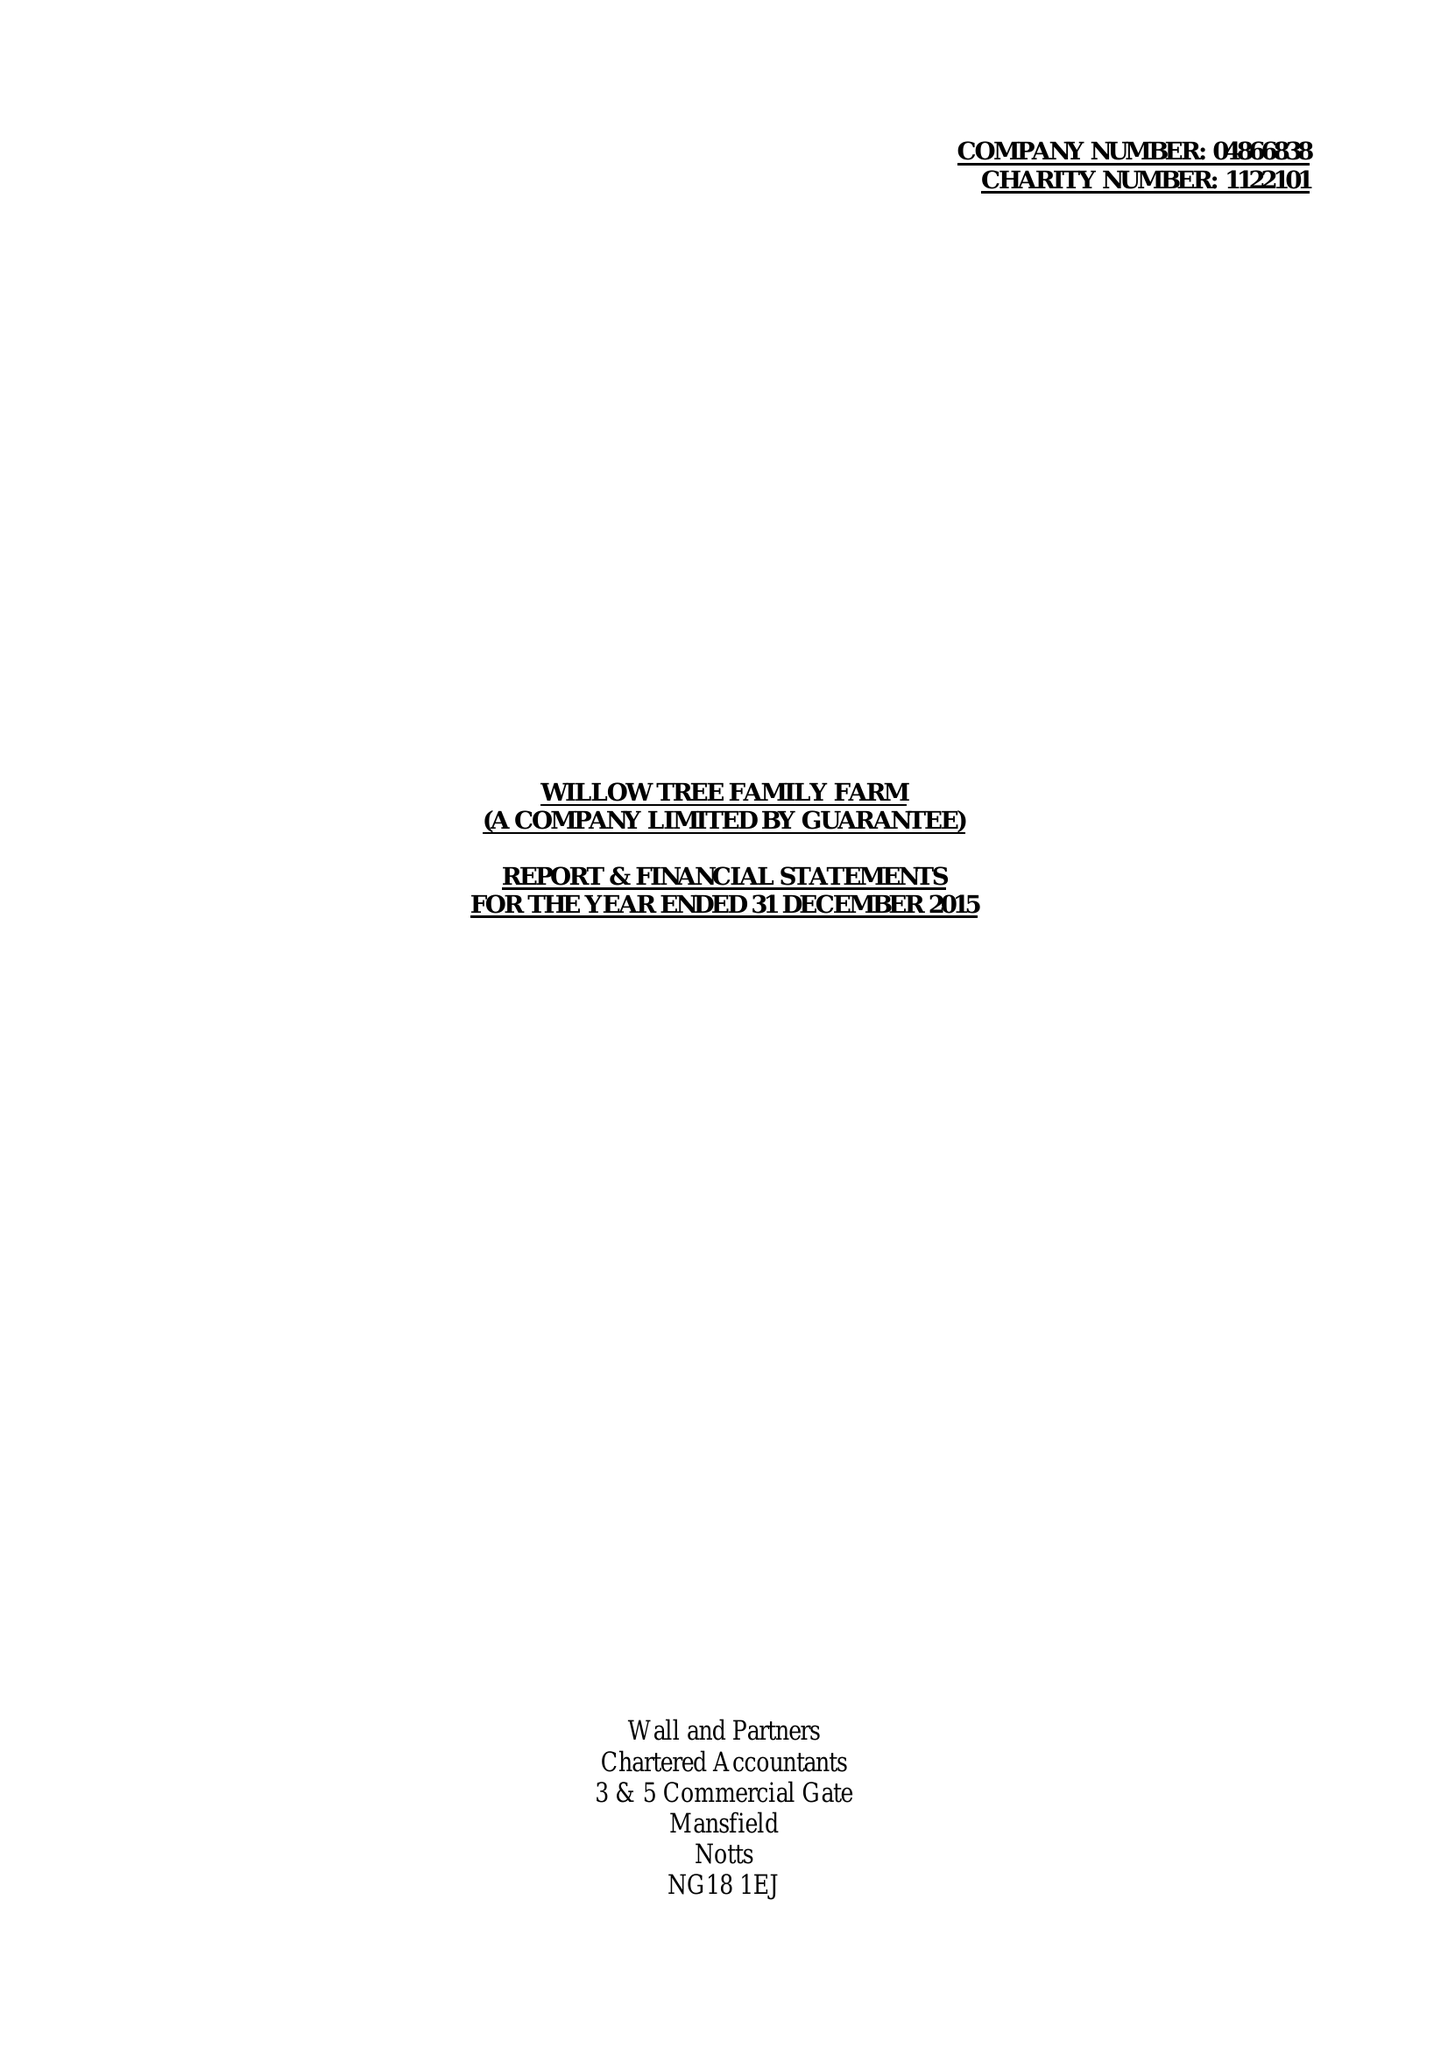What is the value for the spending_annually_in_british_pounds?
Answer the question using a single word or phrase. 128181.00 